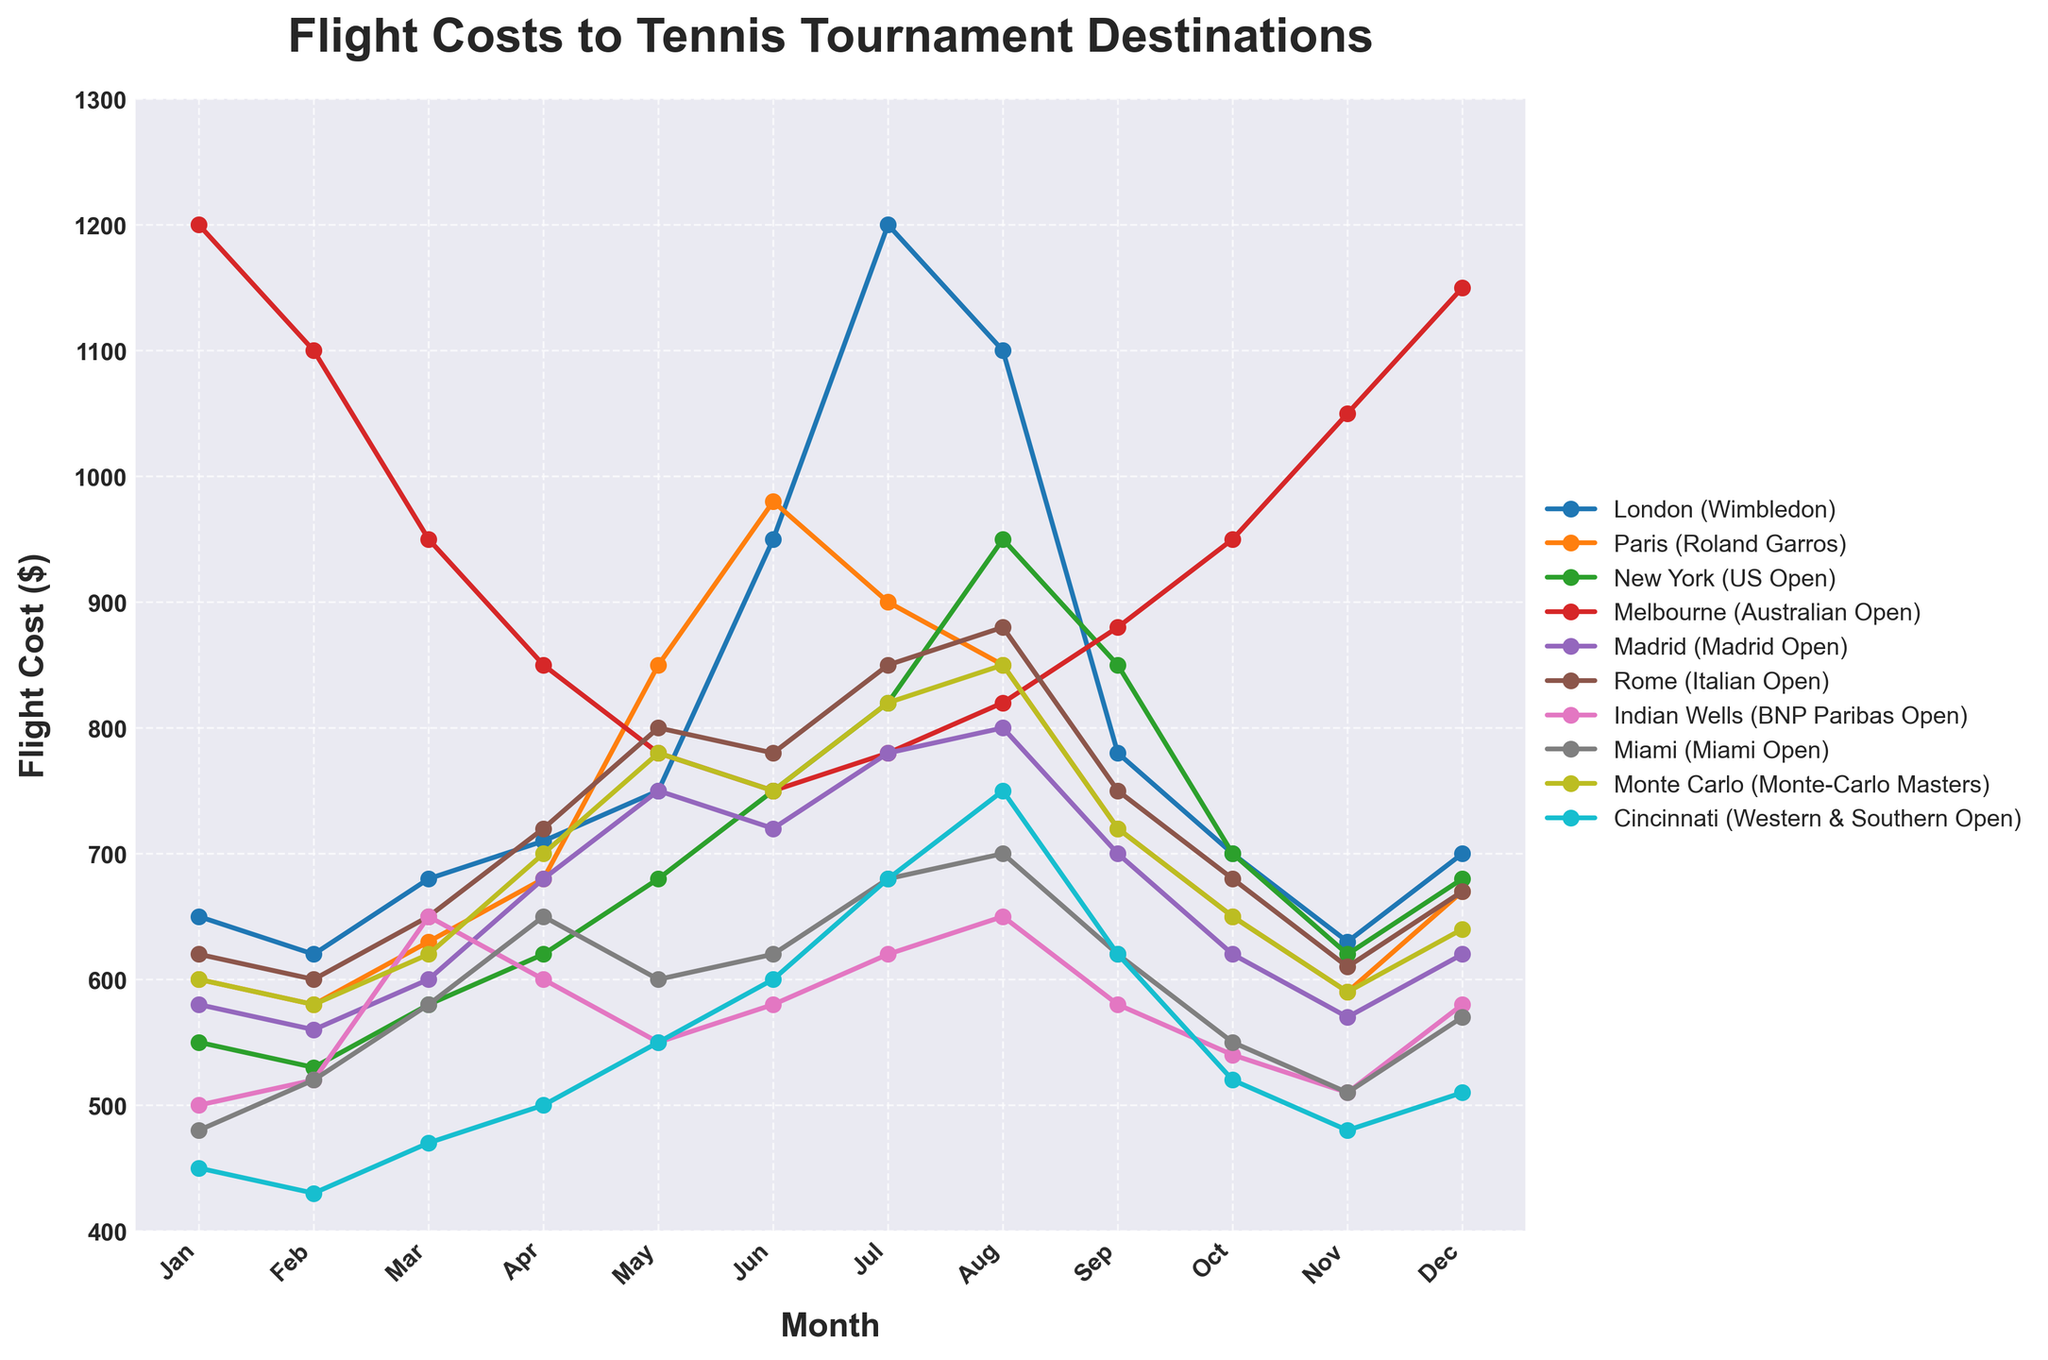Which destination has the highest flight cost in July? Look at the points corresponding to July for all destinations and identify the highest one.
Answer: London (Wimbledon) How does the flight cost to Melbourne (Australian Open) in January compare to December? Find the flight costs for Melbourne in January ($1200) and December ($1150) and compare them.
Answer: January is higher What is the trend of flight costs to New York (US Open) from June to September? Observe the points for New York from June to September, noting any increases or decreases.
Answer: Increasing from June to August, then decreasing Among all destinations, which month has the lowest average flight cost? Calculate the average flight cost for each month across all destinations and identify the lowest one.
Answer: March By how much does the flight cost to Rome (Italian Open) change from April to May? Find the flight costs for Rome in April ($720) and May ($800) and calculate the difference.
Answer: Increase by $80 Is there any month where the Miami Open has the lowest flight cost compared to other destinations? Compare the flight costs for the Miami Open in each month with the costs to all other destinations for the same months.
Answer: No What is the difference between the highest flight cost to London (Wimbledon) and the lowest flight cost to Cincinnati (Western & Southern Open) in the same month? Identify the highest flight cost for London and the lowest for Cincinnati, then calculate the difference.
Answer: July: $1200 (London) - $450 (Cincinnati) = $750 What are the flight costs to Paris (Roland Garros) and Madrid (Madrid Open) in May, and how do they compare? Identify the flight costs for Paris ($850) and Madrid ($750) in May and compare them.
Answer: Paris is higher by $100 Which destination sees the largest increase in flight cost from January to June? Calculate the increase in flight costs from January to June for each destination and identify the largest.
Answer: London (Wimbledon) How does the flight cost trend for Indian Wells (BNP Paribas Open) from January to March compare to Miami (Miami Open) for the same period? Observe the trends for both destinations from January to March and describe them.
Answer: Indian Wells increases, then decreases; Miami increases steadily 